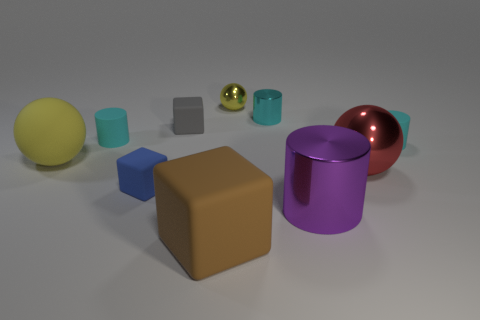Can you describe the lighting and shadows in the scene? The scene is lit in such a way that the objects have soft shadows extending toward the right side, suggesting a light source to the left. The shadows are subtle yet help give the objects a sense of three-dimensional form and indicate their relative position in the space. 